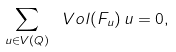<formula> <loc_0><loc_0><loc_500><loc_500>\sum _ { u \in V ( Q ) } \ V o l ( F _ { u } ) \, u = 0 ,</formula> 